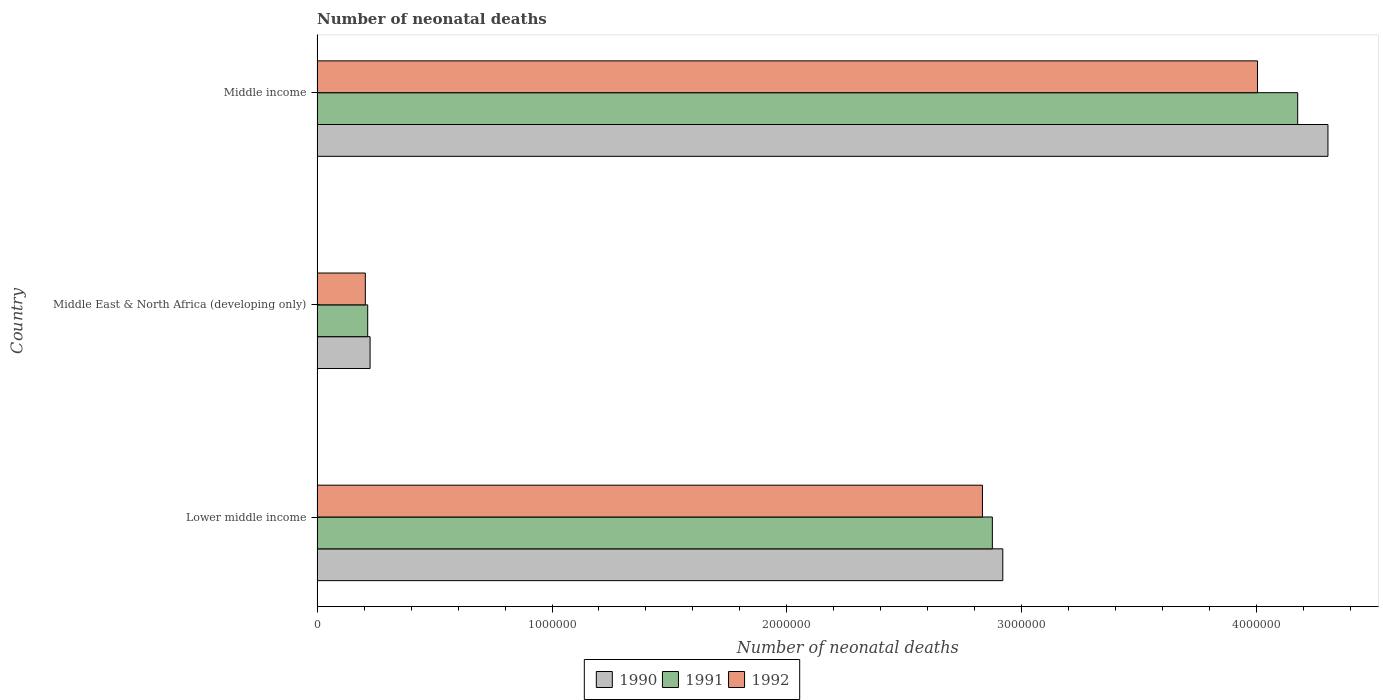How many different coloured bars are there?
Offer a very short reply. 3. Are the number of bars on each tick of the Y-axis equal?
Offer a terse response. Yes. How many bars are there on the 2nd tick from the bottom?
Ensure brevity in your answer.  3. What is the label of the 3rd group of bars from the top?
Make the answer very short. Lower middle income. In how many cases, is the number of bars for a given country not equal to the number of legend labels?
Offer a very short reply. 0. What is the number of neonatal deaths in in 1990 in Lower middle income?
Provide a succinct answer. 2.92e+06. Across all countries, what is the maximum number of neonatal deaths in in 1992?
Ensure brevity in your answer.  4.00e+06. Across all countries, what is the minimum number of neonatal deaths in in 1990?
Make the answer very short. 2.26e+05. In which country was the number of neonatal deaths in in 1992 minimum?
Ensure brevity in your answer.  Middle East & North Africa (developing only). What is the total number of neonatal deaths in in 1991 in the graph?
Keep it short and to the point. 7.26e+06. What is the difference between the number of neonatal deaths in in 1991 in Middle East & North Africa (developing only) and that in Middle income?
Keep it short and to the point. -3.96e+06. What is the difference between the number of neonatal deaths in in 1992 in Middle income and the number of neonatal deaths in in 1990 in Lower middle income?
Provide a short and direct response. 1.08e+06. What is the average number of neonatal deaths in in 1991 per country?
Provide a short and direct response. 2.42e+06. What is the difference between the number of neonatal deaths in in 1991 and number of neonatal deaths in in 1992 in Lower middle income?
Offer a terse response. 4.22e+04. What is the ratio of the number of neonatal deaths in in 1991 in Middle East & North Africa (developing only) to that in Middle income?
Your answer should be compact. 0.05. What is the difference between the highest and the second highest number of neonatal deaths in in 1991?
Provide a short and direct response. 1.30e+06. What is the difference between the highest and the lowest number of neonatal deaths in in 1991?
Give a very brief answer. 3.96e+06. In how many countries, is the number of neonatal deaths in in 1991 greater than the average number of neonatal deaths in in 1991 taken over all countries?
Offer a terse response. 2. Is the sum of the number of neonatal deaths in in 1990 in Lower middle income and Middle East & North Africa (developing only) greater than the maximum number of neonatal deaths in in 1991 across all countries?
Give a very brief answer. No. What does the 3rd bar from the bottom in Middle East & North Africa (developing only) represents?
Provide a succinct answer. 1992. Are all the bars in the graph horizontal?
Make the answer very short. Yes. How many countries are there in the graph?
Provide a short and direct response. 3. Are the values on the major ticks of X-axis written in scientific E-notation?
Your answer should be compact. No. Does the graph contain grids?
Your answer should be very brief. No. How many legend labels are there?
Your response must be concise. 3. How are the legend labels stacked?
Your answer should be very brief. Horizontal. What is the title of the graph?
Provide a succinct answer. Number of neonatal deaths. What is the label or title of the X-axis?
Keep it short and to the point. Number of neonatal deaths. What is the label or title of the Y-axis?
Your response must be concise. Country. What is the Number of neonatal deaths in 1990 in Lower middle income?
Ensure brevity in your answer.  2.92e+06. What is the Number of neonatal deaths in 1991 in Lower middle income?
Your response must be concise. 2.87e+06. What is the Number of neonatal deaths in 1992 in Lower middle income?
Provide a short and direct response. 2.83e+06. What is the Number of neonatal deaths in 1990 in Middle East & North Africa (developing only)?
Ensure brevity in your answer.  2.26e+05. What is the Number of neonatal deaths in 1991 in Middle East & North Africa (developing only)?
Your answer should be compact. 2.16e+05. What is the Number of neonatal deaths in 1992 in Middle East & North Africa (developing only)?
Make the answer very short. 2.05e+05. What is the Number of neonatal deaths in 1990 in Middle income?
Ensure brevity in your answer.  4.30e+06. What is the Number of neonatal deaths in 1991 in Middle income?
Keep it short and to the point. 4.17e+06. What is the Number of neonatal deaths in 1992 in Middle income?
Keep it short and to the point. 4.00e+06. Across all countries, what is the maximum Number of neonatal deaths of 1990?
Your answer should be very brief. 4.30e+06. Across all countries, what is the maximum Number of neonatal deaths in 1991?
Keep it short and to the point. 4.17e+06. Across all countries, what is the maximum Number of neonatal deaths in 1992?
Offer a terse response. 4.00e+06. Across all countries, what is the minimum Number of neonatal deaths of 1990?
Ensure brevity in your answer.  2.26e+05. Across all countries, what is the minimum Number of neonatal deaths in 1991?
Keep it short and to the point. 2.16e+05. Across all countries, what is the minimum Number of neonatal deaths of 1992?
Offer a very short reply. 2.05e+05. What is the total Number of neonatal deaths of 1990 in the graph?
Keep it short and to the point. 7.45e+06. What is the total Number of neonatal deaths in 1991 in the graph?
Make the answer very short. 7.26e+06. What is the total Number of neonatal deaths of 1992 in the graph?
Give a very brief answer. 7.04e+06. What is the difference between the Number of neonatal deaths of 1990 in Lower middle income and that in Middle East & North Africa (developing only)?
Make the answer very short. 2.69e+06. What is the difference between the Number of neonatal deaths of 1991 in Lower middle income and that in Middle East & North Africa (developing only)?
Your answer should be compact. 2.66e+06. What is the difference between the Number of neonatal deaths in 1992 in Lower middle income and that in Middle East & North Africa (developing only)?
Ensure brevity in your answer.  2.63e+06. What is the difference between the Number of neonatal deaths of 1990 in Lower middle income and that in Middle income?
Offer a very short reply. -1.38e+06. What is the difference between the Number of neonatal deaths of 1991 in Lower middle income and that in Middle income?
Your answer should be compact. -1.30e+06. What is the difference between the Number of neonatal deaths in 1992 in Lower middle income and that in Middle income?
Give a very brief answer. -1.17e+06. What is the difference between the Number of neonatal deaths of 1990 in Middle East & North Africa (developing only) and that in Middle income?
Your response must be concise. -4.08e+06. What is the difference between the Number of neonatal deaths in 1991 in Middle East & North Africa (developing only) and that in Middle income?
Offer a terse response. -3.96e+06. What is the difference between the Number of neonatal deaths of 1992 in Middle East & North Africa (developing only) and that in Middle income?
Offer a terse response. -3.80e+06. What is the difference between the Number of neonatal deaths in 1990 in Lower middle income and the Number of neonatal deaths in 1991 in Middle East & North Africa (developing only)?
Offer a very short reply. 2.70e+06. What is the difference between the Number of neonatal deaths of 1990 in Lower middle income and the Number of neonatal deaths of 1992 in Middle East & North Africa (developing only)?
Offer a very short reply. 2.71e+06. What is the difference between the Number of neonatal deaths of 1991 in Lower middle income and the Number of neonatal deaths of 1992 in Middle East & North Africa (developing only)?
Your answer should be compact. 2.67e+06. What is the difference between the Number of neonatal deaths of 1990 in Lower middle income and the Number of neonatal deaths of 1991 in Middle income?
Offer a very short reply. -1.26e+06. What is the difference between the Number of neonatal deaths in 1990 in Lower middle income and the Number of neonatal deaths in 1992 in Middle income?
Give a very brief answer. -1.08e+06. What is the difference between the Number of neonatal deaths in 1991 in Lower middle income and the Number of neonatal deaths in 1992 in Middle income?
Make the answer very short. -1.13e+06. What is the difference between the Number of neonatal deaths of 1990 in Middle East & North Africa (developing only) and the Number of neonatal deaths of 1991 in Middle income?
Provide a succinct answer. -3.95e+06. What is the difference between the Number of neonatal deaths in 1990 in Middle East & North Africa (developing only) and the Number of neonatal deaths in 1992 in Middle income?
Make the answer very short. -3.78e+06. What is the difference between the Number of neonatal deaths of 1991 in Middle East & North Africa (developing only) and the Number of neonatal deaths of 1992 in Middle income?
Your answer should be very brief. -3.79e+06. What is the average Number of neonatal deaths in 1990 per country?
Give a very brief answer. 2.48e+06. What is the average Number of neonatal deaths in 1991 per country?
Your response must be concise. 2.42e+06. What is the average Number of neonatal deaths in 1992 per country?
Provide a succinct answer. 2.35e+06. What is the difference between the Number of neonatal deaths of 1990 and Number of neonatal deaths of 1991 in Lower middle income?
Keep it short and to the point. 4.44e+04. What is the difference between the Number of neonatal deaths of 1990 and Number of neonatal deaths of 1992 in Lower middle income?
Your response must be concise. 8.66e+04. What is the difference between the Number of neonatal deaths of 1991 and Number of neonatal deaths of 1992 in Lower middle income?
Provide a succinct answer. 4.22e+04. What is the difference between the Number of neonatal deaths in 1990 and Number of neonatal deaths in 1991 in Middle East & North Africa (developing only)?
Give a very brief answer. 1.01e+04. What is the difference between the Number of neonatal deaths of 1990 and Number of neonatal deaths of 1992 in Middle East & North Africa (developing only)?
Provide a short and direct response. 2.03e+04. What is the difference between the Number of neonatal deaths in 1991 and Number of neonatal deaths in 1992 in Middle East & North Africa (developing only)?
Your answer should be compact. 1.02e+04. What is the difference between the Number of neonatal deaths in 1990 and Number of neonatal deaths in 1991 in Middle income?
Keep it short and to the point. 1.29e+05. What is the difference between the Number of neonatal deaths of 1990 and Number of neonatal deaths of 1992 in Middle income?
Provide a succinct answer. 3.00e+05. What is the difference between the Number of neonatal deaths of 1991 and Number of neonatal deaths of 1992 in Middle income?
Make the answer very short. 1.71e+05. What is the ratio of the Number of neonatal deaths of 1990 in Lower middle income to that in Middle East & North Africa (developing only)?
Your response must be concise. 12.93. What is the ratio of the Number of neonatal deaths in 1991 in Lower middle income to that in Middle East & North Africa (developing only)?
Provide a short and direct response. 13.33. What is the ratio of the Number of neonatal deaths in 1992 in Lower middle income to that in Middle East & North Africa (developing only)?
Your answer should be compact. 13.79. What is the ratio of the Number of neonatal deaths of 1990 in Lower middle income to that in Middle income?
Give a very brief answer. 0.68. What is the ratio of the Number of neonatal deaths in 1991 in Lower middle income to that in Middle income?
Keep it short and to the point. 0.69. What is the ratio of the Number of neonatal deaths in 1992 in Lower middle income to that in Middle income?
Your answer should be compact. 0.71. What is the ratio of the Number of neonatal deaths in 1990 in Middle East & North Africa (developing only) to that in Middle income?
Your answer should be very brief. 0.05. What is the ratio of the Number of neonatal deaths of 1991 in Middle East & North Africa (developing only) to that in Middle income?
Ensure brevity in your answer.  0.05. What is the ratio of the Number of neonatal deaths of 1992 in Middle East & North Africa (developing only) to that in Middle income?
Keep it short and to the point. 0.05. What is the difference between the highest and the second highest Number of neonatal deaths of 1990?
Provide a short and direct response. 1.38e+06. What is the difference between the highest and the second highest Number of neonatal deaths in 1991?
Your answer should be very brief. 1.30e+06. What is the difference between the highest and the second highest Number of neonatal deaths in 1992?
Provide a succinct answer. 1.17e+06. What is the difference between the highest and the lowest Number of neonatal deaths in 1990?
Provide a short and direct response. 4.08e+06. What is the difference between the highest and the lowest Number of neonatal deaths in 1991?
Provide a succinct answer. 3.96e+06. What is the difference between the highest and the lowest Number of neonatal deaths of 1992?
Your answer should be very brief. 3.80e+06. 